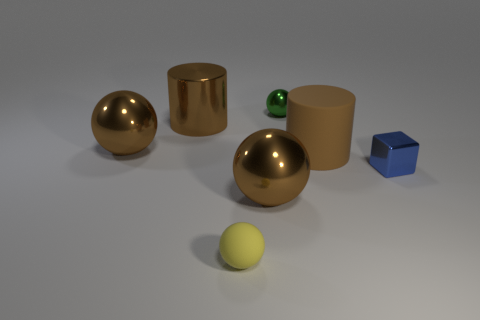Is there any other thing that is made of the same material as the blue cube?
Provide a short and direct response. Yes. Does the large brown matte object have the same shape as the brown thing left of the big metallic cylinder?
Ensure brevity in your answer.  No. How many other things are there of the same size as the brown shiny cylinder?
Provide a short and direct response. 3. What number of brown things are large rubber things or large shiny cylinders?
Your answer should be compact. 2. How many things are in front of the matte cylinder and right of the small metallic sphere?
Provide a succinct answer. 1. What is the large brown cylinder right of the small sphere behind the brown shiny ball that is in front of the tiny blue metal thing made of?
Make the answer very short. Rubber. How many big brown cylinders are the same material as the small blue thing?
Offer a very short reply. 1. What shape is the large matte thing that is the same color as the metal cylinder?
Keep it short and to the point. Cylinder. What shape is the blue thing that is the same size as the green metal object?
Offer a terse response. Cube. There is another big cylinder that is the same color as the large matte cylinder; what material is it?
Your response must be concise. Metal. 